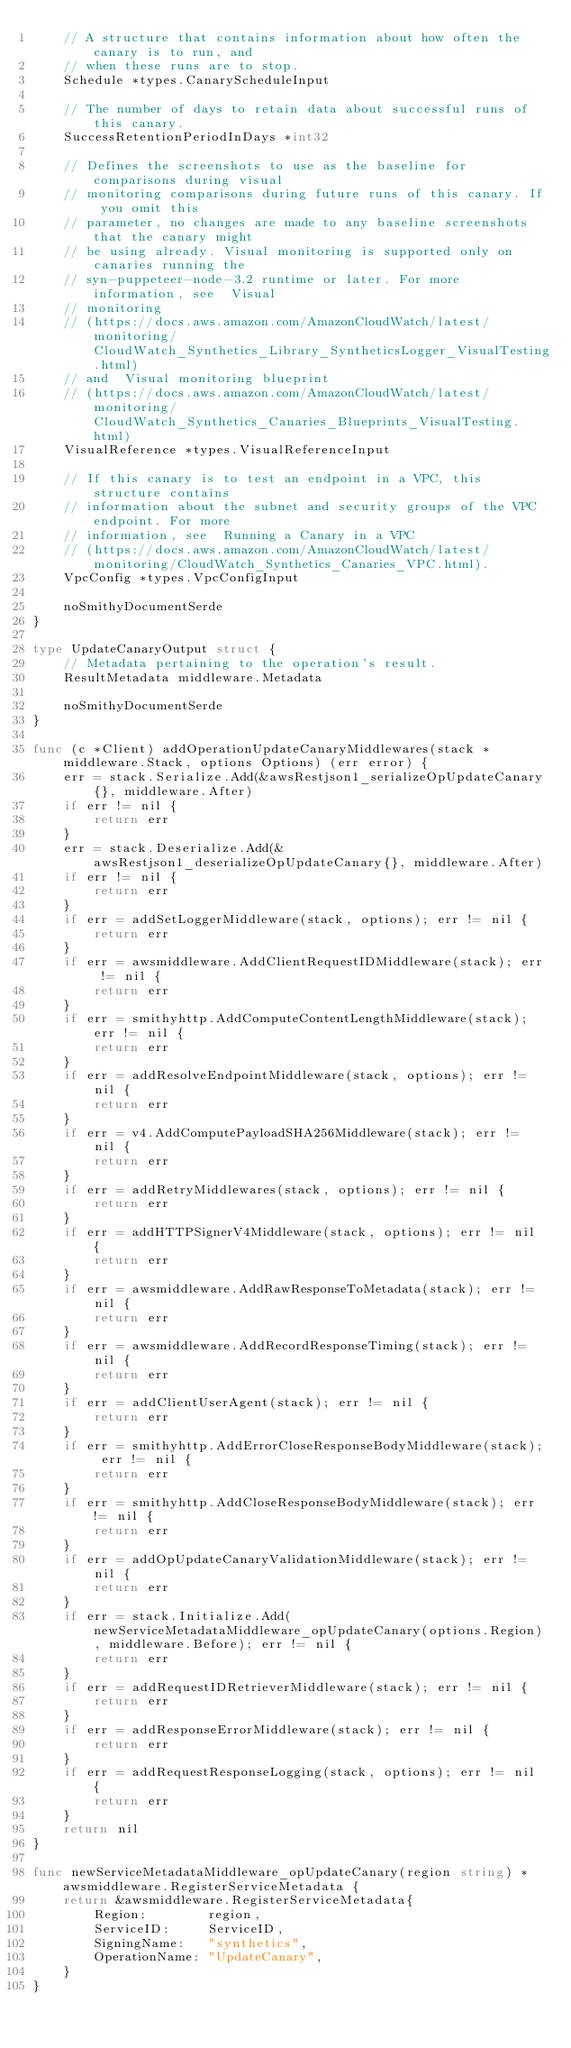<code> <loc_0><loc_0><loc_500><loc_500><_Go_>	// A structure that contains information about how often the canary is to run, and
	// when these runs are to stop.
	Schedule *types.CanaryScheduleInput

	// The number of days to retain data about successful runs of this canary.
	SuccessRetentionPeriodInDays *int32

	// Defines the screenshots to use as the baseline for comparisons during visual
	// monitoring comparisons during future runs of this canary. If you omit this
	// parameter, no changes are made to any baseline screenshots that the canary might
	// be using already. Visual monitoring is supported only on canaries running the
	// syn-puppeteer-node-3.2 runtime or later. For more information, see  Visual
	// monitoring
	// (https://docs.aws.amazon.com/AmazonCloudWatch/latest/monitoring/CloudWatch_Synthetics_Library_SyntheticsLogger_VisualTesting.html)
	// and  Visual monitoring blueprint
	// (https://docs.aws.amazon.com/AmazonCloudWatch/latest/monitoring/CloudWatch_Synthetics_Canaries_Blueprints_VisualTesting.html)
	VisualReference *types.VisualReferenceInput

	// If this canary is to test an endpoint in a VPC, this structure contains
	// information about the subnet and security groups of the VPC endpoint. For more
	// information, see  Running a Canary in a VPC
	// (https://docs.aws.amazon.com/AmazonCloudWatch/latest/monitoring/CloudWatch_Synthetics_Canaries_VPC.html).
	VpcConfig *types.VpcConfigInput

	noSmithyDocumentSerde
}

type UpdateCanaryOutput struct {
	// Metadata pertaining to the operation's result.
	ResultMetadata middleware.Metadata

	noSmithyDocumentSerde
}

func (c *Client) addOperationUpdateCanaryMiddlewares(stack *middleware.Stack, options Options) (err error) {
	err = stack.Serialize.Add(&awsRestjson1_serializeOpUpdateCanary{}, middleware.After)
	if err != nil {
		return err
	}
	err = stack.Deserialize.Add(&awsRestjson1_deserializeOpUpdateCanary{}, middleware.After)
	if err != nil {
		return err
	}
	if err = addSetLoggerMiddleware(stack, options); err != nil {
		return err
	}
	if err = awsmiddleware.AddClientRequestIDMiddleware(stack); err != nil {
		return err
	}
	if err = smithyhttp.AddComputeContentLengthMiddleware(stack); err != nil {
		return err
	}
	if err = addResolveEndpointMiddleware(stack, options); err != nil {
		return err
	}
	if err = v4.AddComputePayloadSHA256Middleware(stack); err != nil {
		return err
	}
	if err = addRetryMiddlewares(stack, options); err != nil {
		return err
	}
	if err = addHTTPSignerV4Middleware(stack, options); err != nil {
		return err
	}
	if err = awsmiddleware.AddRawResponseToMetadata(stack); err != nil {
		return err
	}
	if err = awsmiddleware.AddRecordResponseTiming(stack); err != nil {
		return err
	}
	if err = addClientUserAgent(stack); err != nil {
		return err
	}
	if err = smithyhttp.AddErrorCloseResponseBodyMiddleware(stack); err != nil {
		return err
	}
	if err = smithyhttp.AddCloseResponseBodyMiddleware(stack); err != nil {
		return err
	}
	if err = addOpUpdateCanaryValidationMiddleware(stack); err != nil {
		return err
	}
	if err = stack.Initialize.Add(newServiceMetadataMiddleware_opUpdateCanary(options.Region), middleware.Before); err != nil {
		return err
	}
	if err = addRequestIDRetrieverMiddleware(stack); err != nil {
		return err
	}
	if err = addResponseErrorMiddleware(stack); err != nil {
		return err
	}
	if err = addRequestResponseLogging(stack, options); err != nil {
		return err
	}
	return nil
}

func newServiceMetadataMiddleware_opUpdateCanary(region string) *awsmiddleware.RegisterServiceMetadata {
	return &awsmiddleware.RegisterServiceMetadata{
		Region:        region,
		ServiceID:     ServiceID,
		SigningName:   "synthetics",
		OperationName: "UpdateCanary",
	}
}
</code> 